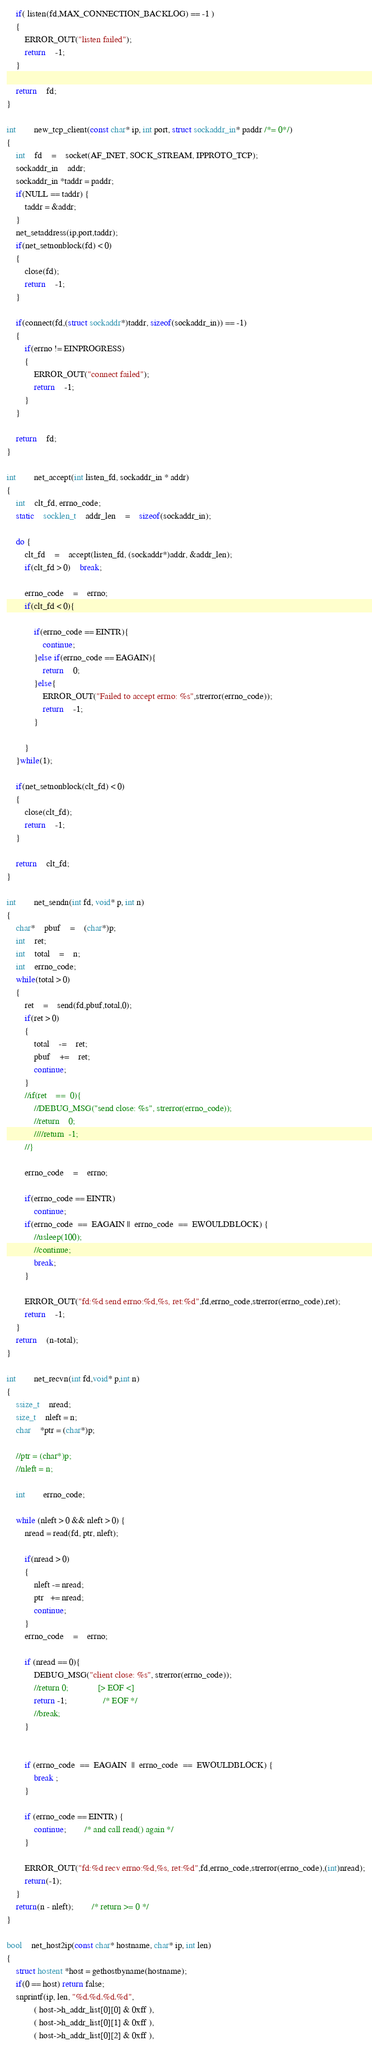<code> <loc_0><loc_0><loc_500><loc_500><_C++_>	if( listen(fd,MAX_CONNECTION_BACKLOG) == -1 )
	{
		ERROR_OUT("listen failed");
		return	-1;
	}

	return	fd;
}

int		new_tcp_client(const char* ip, int port, struct sockaddr_in* paddr /*= 0*/)
{
	int	fd	=	socket(AF_INET, SOCK_STREAM, IPPROTO_TCP);
	sockaddr_in	addr;
	sockaddr_in *taddr = paddr;
	if(NULL == taddr) {
		taddr = &addr;
	}
	net_setaddress(ip,port,taddr);
	if(net_setnonblock(fd) < 0)
	{
		close(fd);
		return	-1;
	}

	if(connect(fd,(struct sockaddr*)taddr, sizeof(sockaddr_in)) == -1)
	{
		if(errno != EINPROGRESS)
		{
			ERROR_OUT("connect failed");
			return	-1;
		}
	}

	return	fd;
}

int		net_accept(int listen_fd, sockaddr_in * addr)
{
	int	clt_fd, errno_code;
	static	socklen_t	addr_len	=	sizeof(sockaddr_in);

	do {
		clt_fd	=	accept(listen_fd, (sockaddr*)addr, &addr_len);
		if(clt_fd > 0)	break;

		errno_code	=	errno;
		if(clt_fd < 0){

			if(errno_code == EINTR){
				continue;
			}else if(errno_code == EAGAIN){
				return	0;
			}else{
				ERROR_OUT("Failed to accept errno: %s",strerror(errno_code));
				return	-1;
			}

		}
	}while(1);

	if(net_setnonblock(clt_fd) < 0)
	{
		close(clt_fd);
		return	-1;
	}

	return	clt_fd;
}

int		net_sendn(int fd, void* p, int n)
{
	char*	pbuf	=	(char*)p;
	int	ret;
	int	total	=	n;
	int	errno_code;
	while(total > 0)
	{
		ret	=	send(fd,pbuf,total,0);
		if(ret > 0)
		{
			total	-=	ret;
			pbuf	+=	ret;
			continue;
		}
		//if(ret	==	0){
			//DEBUG_MSG("send close: %s", strerror(errno_code));
			//return	0;
			////return	-1;
		//}

		errno_code	=	errno;

		if(errno_code == EINTR)
			continue;
		if(errno_code  ==  EAGAIN ||  errno_code  ==  EWOULDBLOCK) {
			//usleep(100);
			//continue;
			break;
		}

		ERROR_OUT("fd:%d send errno:%d,%s, ret:%d",fd,errno_code,strerror(errno_code),ret);
		return	-1;
	}
	return	(n-total);
}

int		net_recvn(int fd,void* p,int n)
{
	ssize_t	nread;
	size_t	nleft = n;
	char	*ptr = (char*)p;

	//ptr = (char*)p;
	//nleft = n;

	int		errno_code;

	while (nleft > 0 && nleft > 0) {
		nread = read(fd, ptr, nleft);

		if(nread > 0)
		{
			nleft -= nread;
			ptr   += nread;
			continue;
		}
		errno_code	=	errno;

		if (nread == 0){
			DEBUG_MSG("client close: %s", strerror(errno_code));
			//return 0;				[> EOF <]
			return -1;				/* EOF */
			//break;
		}


		if (errno_code  ==  EAGAIN  ||  errno_code  ==  EWOULDBLOCK) {
			break ;
		}

		if (errno_code == EINTR) {
			continue;		/* and call read() again */
		}

		ERROR_OUT("fd:%d recv errno:%d,%s, ret:%d",fd,errno_code,strerror(errno_code),(int)nread);
		return(-1);
	}
	return(n - nleft);		/* return >= 0 */
}

bool	net_host2ip(const char* hostname, char* ip, int len)
{
	struct hostent *host = gethostbyname(hostname);
	if(0 == host) return false;
	snprintf(ip, len, "%d.%d.%d.%d",
			( host->h_addr_list[0][0] & 0xff ),
			( host->h_addr_list[0][1] & 0xff ),
			( host->h_addr_list[0][2] & 0xff ),</code> 